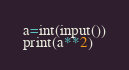<code> <loc_0><loc_0><loc_500><loc_500><_Python_>a=int(input())
print(a**2)</code> 